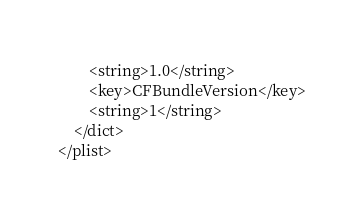Convert code to text. <code><loc_0><loc_0><loc_500><loc_500><_XML_>		<string>1.0</string>
		<key>CFBundleVersion</key>
		<string>1</string>
	</dict>
</plist>
</code> 